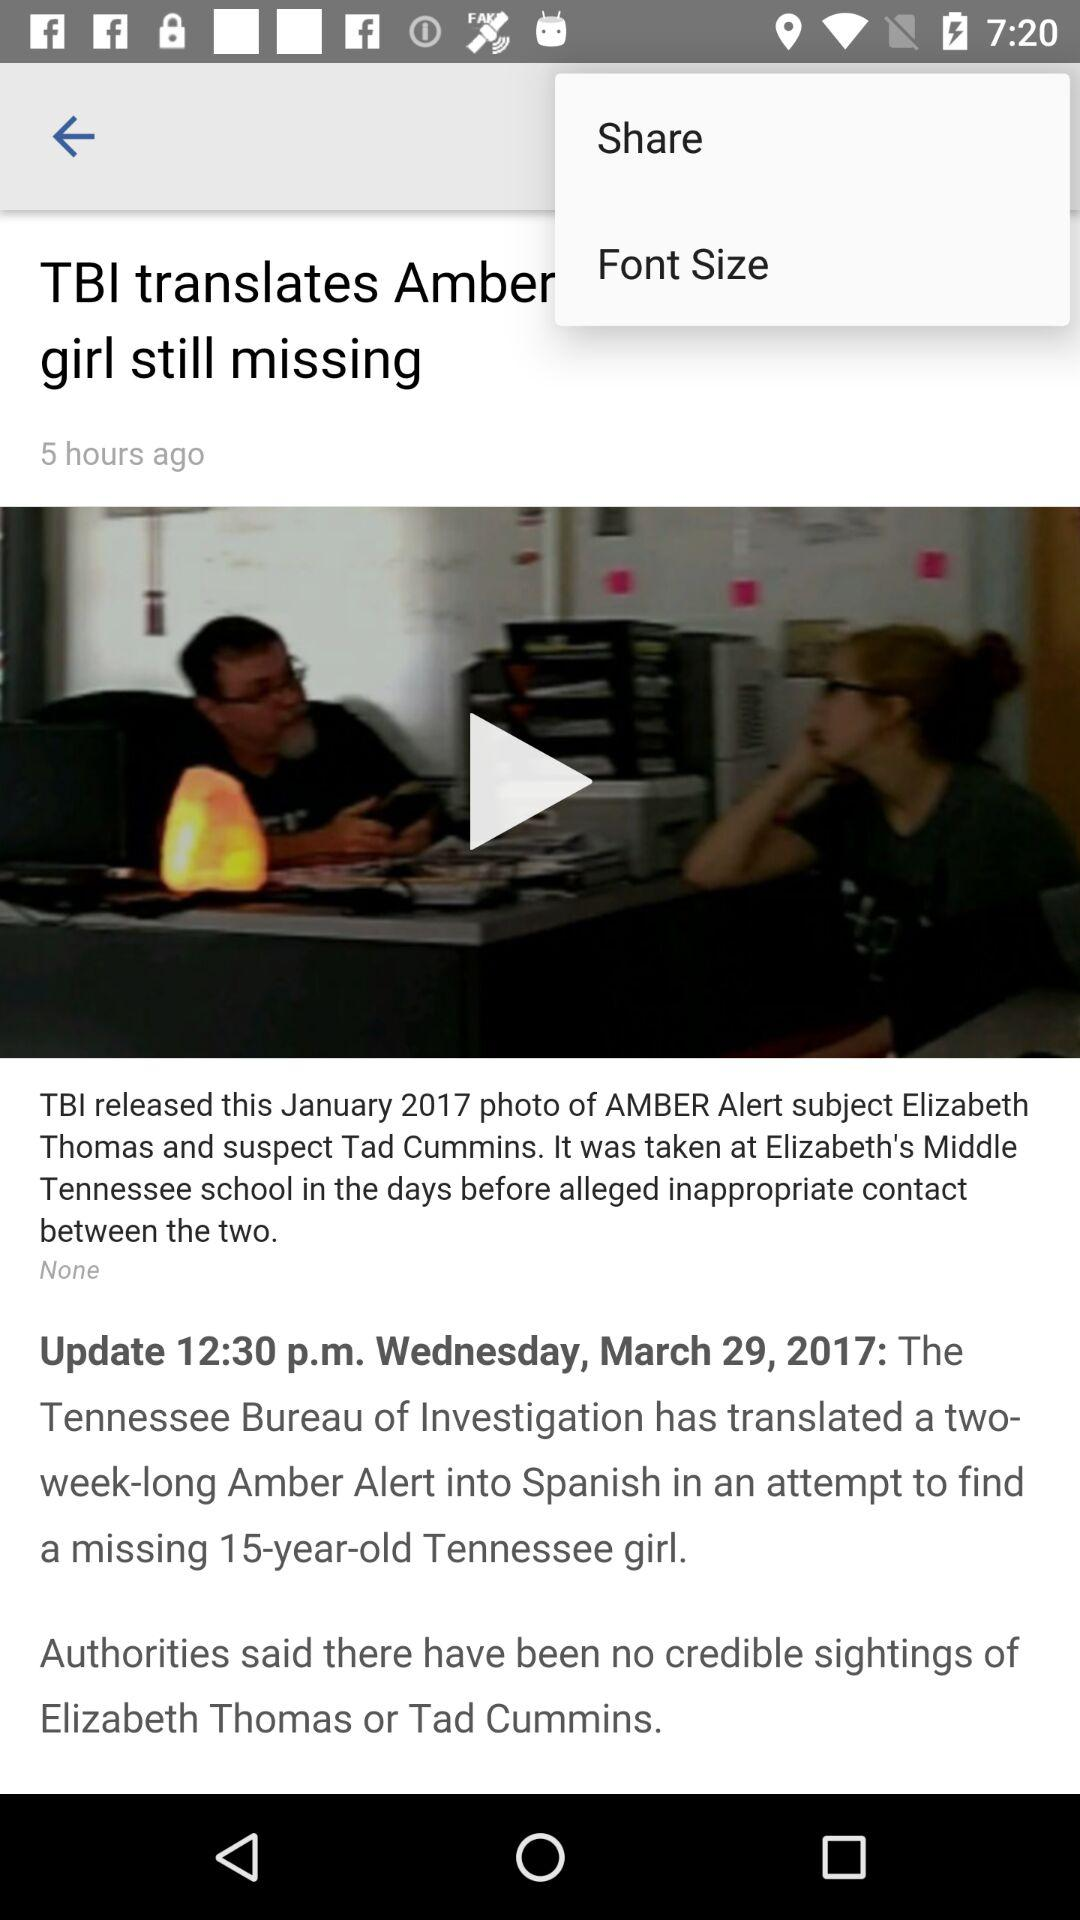What's the time when the news was updated? The news was updated at 12:30 p.m. 